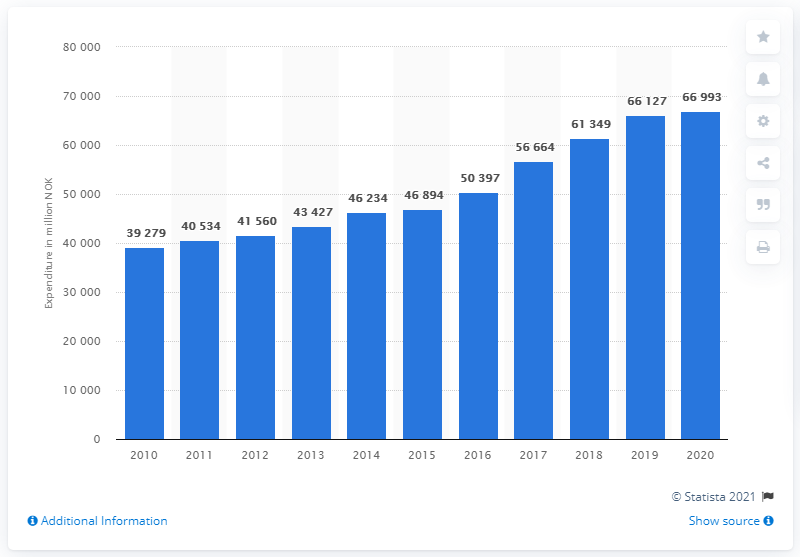Draw attention to some important aspects in this diagram. The military expenditure in Norway in 2020 was 66,993. 